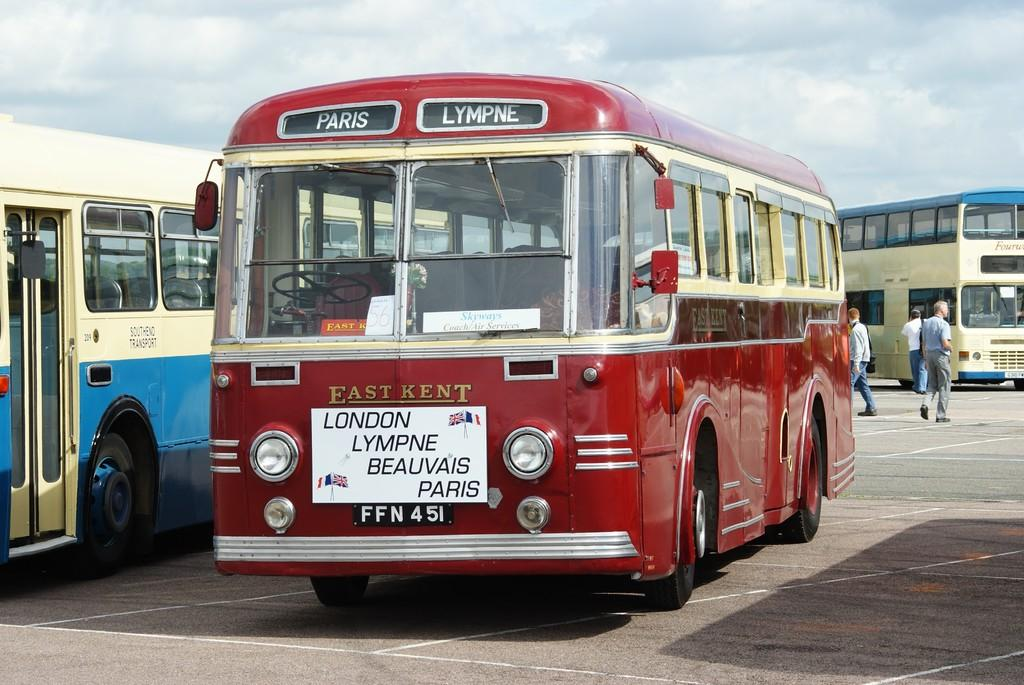How many buses can be seen on the road in the image? There are three buses on the road in the image. What are the people on the right side of the image doing? Three men are walking on the right side in the image. What is visible at the top of the image? The sky is visible at the top of the image. Can you see a squirrel climbing a tree in the image? There is no squirrel or tree present in the image. Is there any quicksand visible on the road in the image? There is no quicksand visible on the road in the image. 